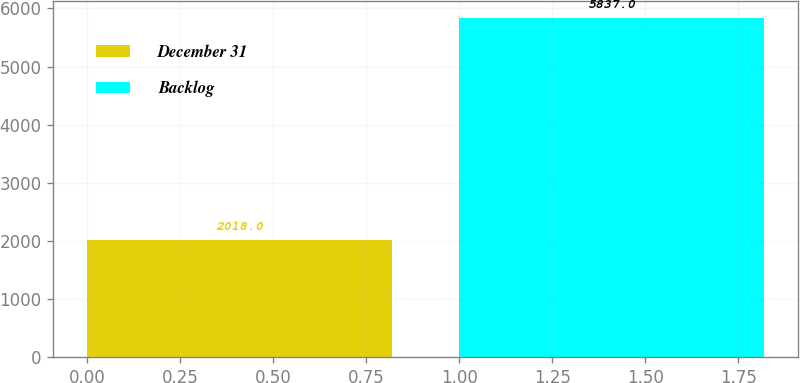Convert chart to OTSL. <chart><loc_0><loc_0><loc_500><loc_500><bar_chart><fcel>December 31<fcel>Backlog<nl><fcel>2018<fcel>5837<nl></chart> 